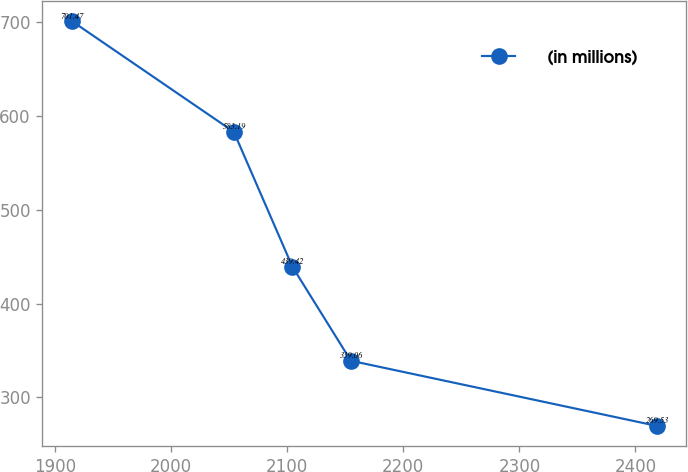Convert chart. <chart><loc_0><loc_0><loc_500><loc_500><line_chart><ecel><fcel>(in millions)<nl><fcel>1914.22<fcel>701.47<nl><fcel>2053.91<fcel>583.19<nl><fcel>2104.34<fcel>439.42<nl><fcel>2154.77<fcel>339.06<nl><fcel>2418.49<fcel>269.53<nl></chart> 